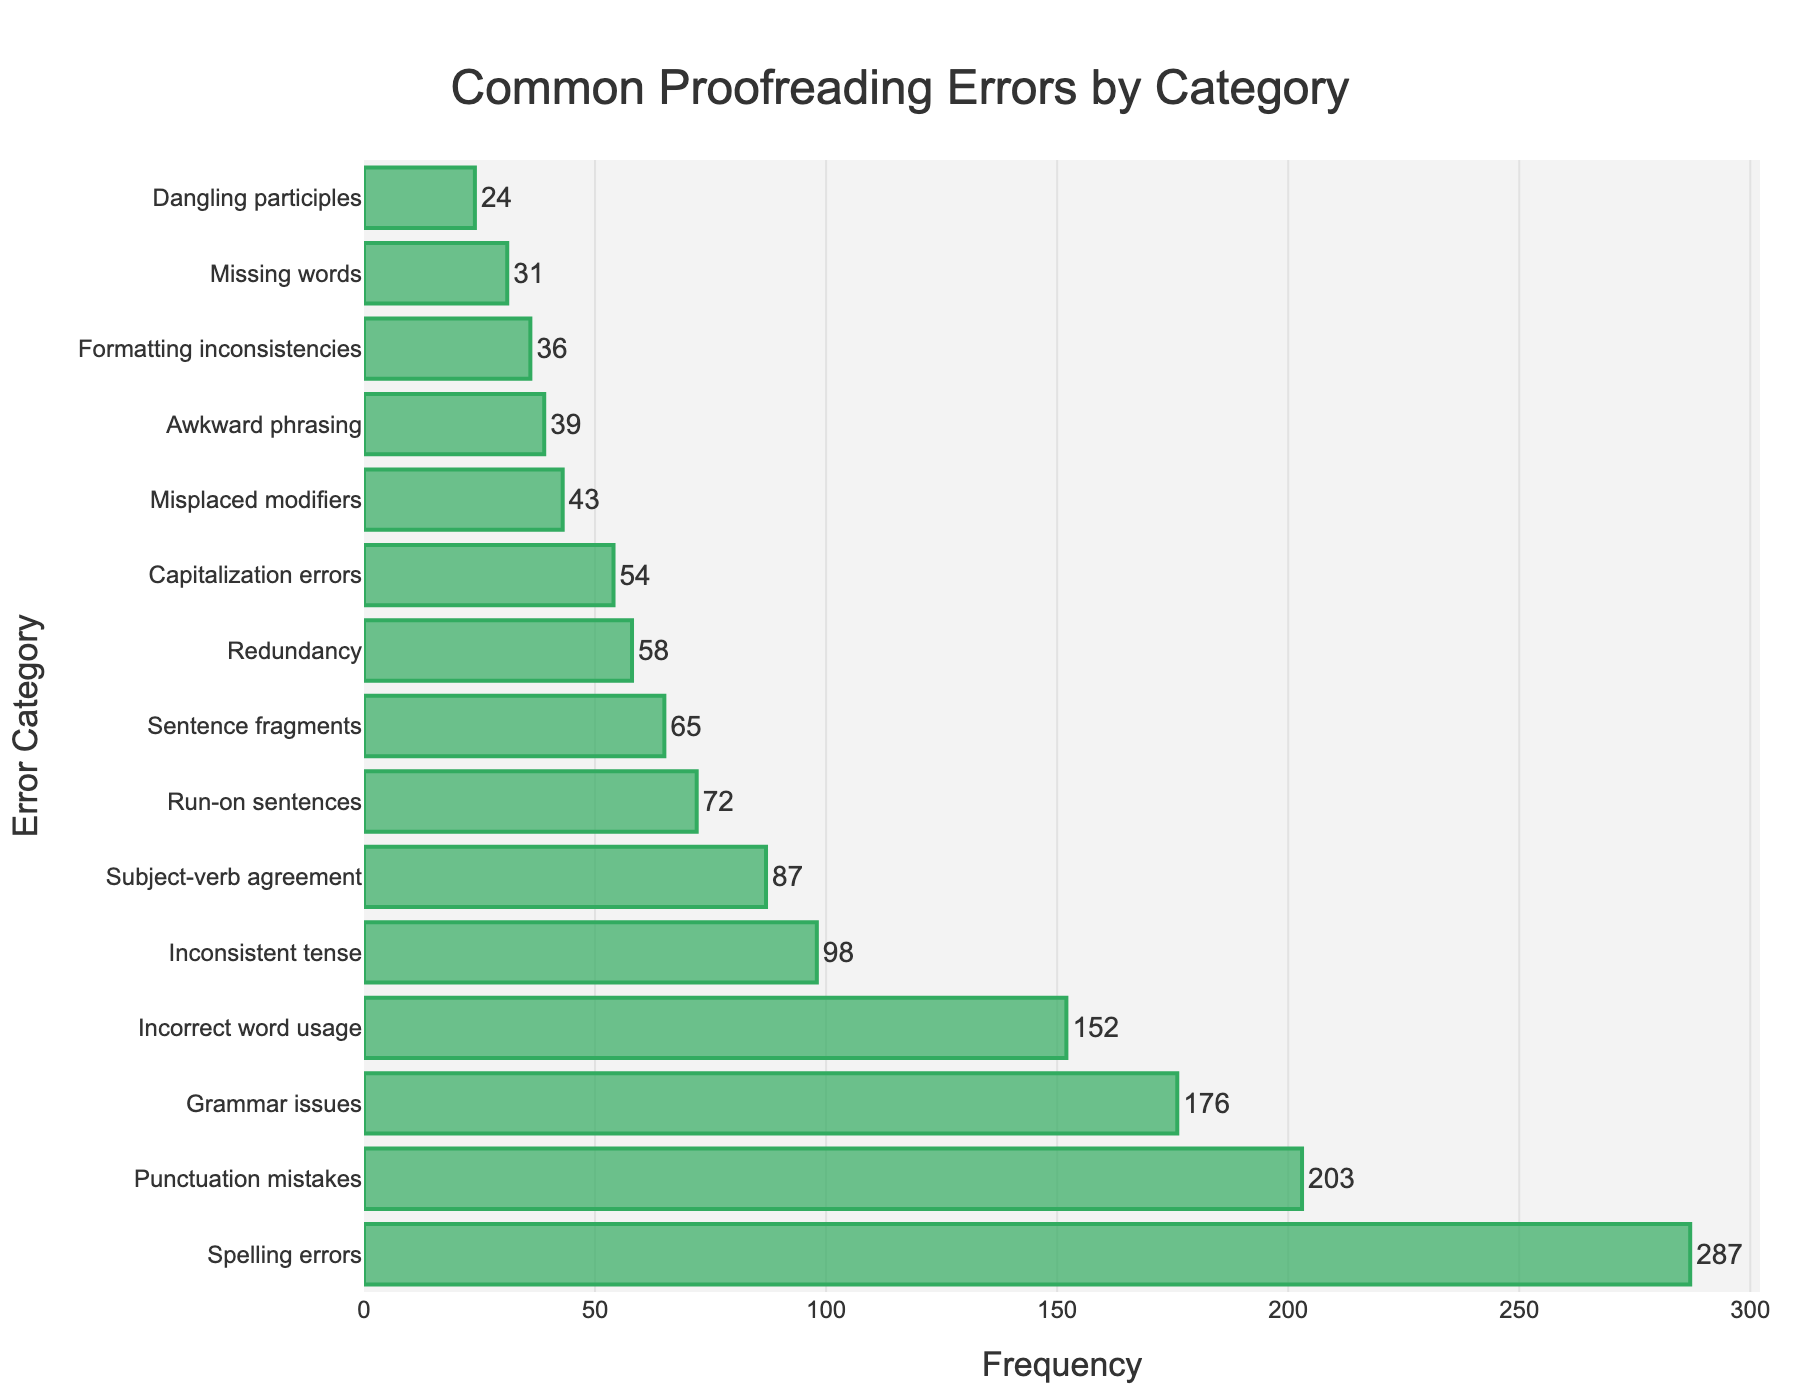What category has the highest frequency of errors? The bar chart shows that "Spelling errors" has the highest frequency. By looking at the length of all bars, we see that the bar for "Spelling errors" extends the farthest to the right.
Answer: Spelling errors Which error category has the lowest frequency? The category "Dangling participles" has the lowest frequency. The bar for "Dangling participles" is the shortest among all the bars in the chart.
Answer: Dangling participles How many more "Spelling errors" are there compared to "Punctuation mistakes"? The frequency of "Spelling errors" is 287 and "Punctuation mistakes" is 203. Subtracting the two gives 287 - 203 = 84.
Answer: 84 Are there more "Awkward phrasing" errors or "Formatting inconsistencies"? There are more "Awkward phrasing" errors with a frequency of 39 compared to "Formatting inconsistencies," which has a frequency of 36.
Answer: Awkward phrasing What is the sum of "Incorrect word usage" and "Inconsistent tense" errors? The frequency of "Incorrect word usage" is 152, and "Inconsistent tense" is 98. Adding them gives 152 + 98 = 250.
Answer: 250 Is the frequency of "Grammar issues" greater than "Subject-verb agreement"? Yes, the frequency of "Grammar issues" is 176, which is greater than the "Subject-verb agreement" frequency of 87.
Answer: Yes What is the ratio of "Punctuation mistakes" to "Run-on sentences"? The frequency of "Punctuation mistakes" is 203, and "Run-on sentences" is 72. Dividing the two gives a ratio of 203 / 72 ≈ 2.82.
Answer: 2.82 How many error categories have a frequency above 100? By counting the bars with a frequency extending beyond the 100 mark, we find there are 5 categories: "Spelling errors," "Punctuation mistakes," "Grammar issues," "Incorrect word usage," and "Inconsistent tense."
Answer: 5 What is the total frequency of all error categories combined? Summing the frequencies of all categories: 287 + 203 + 176 + 152 + 98 + 87 + 72 + 65 + 58 + 54 + 43 + 39 + 36 + 31 + 24 = 1425.
Answer: 1425 